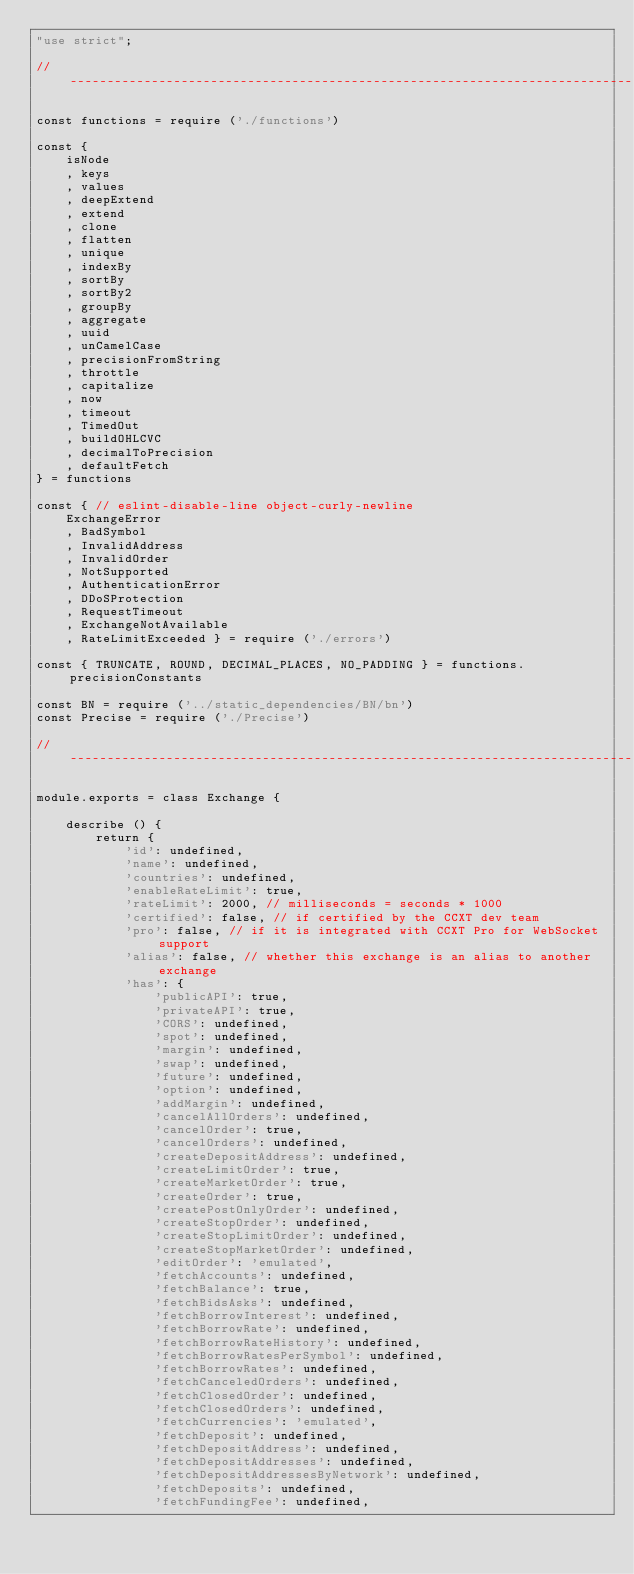<code> <loc_0><loc_0><loc_500><loc_500><_JavaScript_>"use strict";

// ----------------------------------------------------------------------------

const functions = require ('./functions')

const {
    isNode
    , keys
    , values
    , deepExtend
    , extend
    , clone
    , flatten
    , unique
    , indexBy
    , sortBy
    , sortBy2
    , groupBy
    , aggregate
    , uuid
    , unCamelCase
    , precisionFromString
    , throttle
    , capitalize
    , now
    , timeout
    , TimedOut
    , buildOHLCVC
    , decimalToPrecision
    , defaultFetch
} = functions

const { // eslint-disable-line object-curly-newline
    ExchangeError
    , BadSymbol
    , InvalidAddress
    , InvalidOrder
    , NotSupported
    , AuthenticationError
    , DDoSProtection
    , RequestTimeout
    , ExchangeNotAvailable
    , RateLimitExceeded } = require ('./errors')

const { TRUNCATE, ROUND, DECIMAL_PLACES, NO_PADDING } = functions.precisionConstants

const BN = require ('../static_dependencies/BN/bn')
const Precise = require ('./Precise')

// ----------------------------------------------------------------------------

module.exports = class Exchange {

    describe () {
        return {
            'id': undefined,
            'name': undefined,
            'countries': undefined,
            'enableRateLimit': true,
            'rateLimit': 2000, // milliseconds = seconds * 1000
            'certified': false, // if certified by the CCXT dev team
            'pro': false, // if it is integrated with CCXT Pro for WebSocket support
            'alias': false, // whether this exchange is an alias to another exchange
            'has': {
                'publicAPI': true,
                'privateAPI': true,
                'CORS': undefined,
                'spot': undefined,
                'margin': undefined,
                'swap': undefined,
                'future': undefined,
                'option': undefined,
                'addMargin': undefined,
                'cancelAllOrders': undefined,
                'cancelOrder': true,
                'cancelOrders': undefined,
                'createDepositAddress': undefined,
                'createLimitOrder': true,
                'createMarketOrder': true,
                'createOrder': true,
                'createPostOnlyOrder': undefined,
                'createStopOrder': undefined,
                'createStopLimitOrder': undefined,
                'createStopMarketOrder': undefined,
                'editOrder': 'emulated',
                'fetchAccounts': undefined,
                'fetchBalance': true,
                'fetchBidsAsks': undefined,
                'fetchBorrowInterest': undefined,
                'fetchBorrowRate': undefined,
                'fetchBorrowRateHistory': undefined,
                'fetchBorrowRatesPerSymbol': undefined,
                'fetchBorrowRates': undefined,
                'fetchCanceledOrders': undefined,
                'fetchClosedOrder': undefined,
                'fetchClosedOrders': undefined,
                'fetchCurrencies': 'emulated',
                'fetchDeposit': undefined,
                'fetchDepositAddress': undefined,
                'fetchDepositAddresses': undefined,
                'fetchDepositAddressesByNetwork': undefined,
                'fetchDeposits': undefined,
                'fetchFundingFee': undefined,</code> 